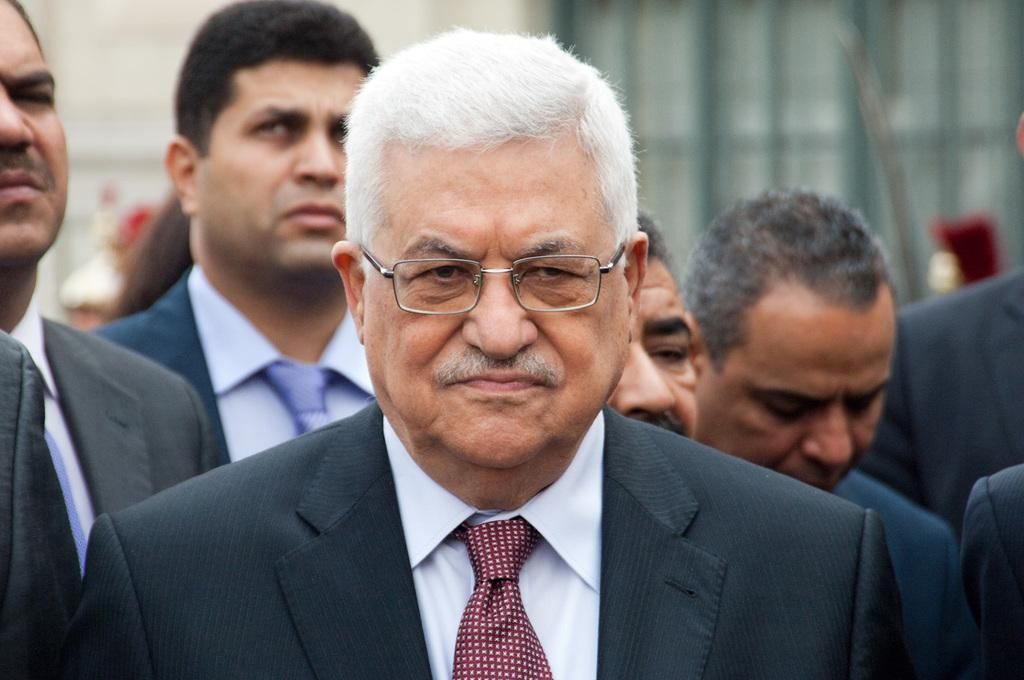What is the main subject at the bottom of the image? There is a person in a suit at the bottom of the image. What can be observed about the person's appearance? The person is wearing spectacles. What else can be seen in the image besides the person in a suit? There are other persons in the background of the image. How would you describe the background of the image? The background is blurred. What feeling does the person in the suit have while looking at the memory in the image? There is no indication of any feelings or memories in the image; it only shows a person in a suit with spectacles and other persons in the background. 